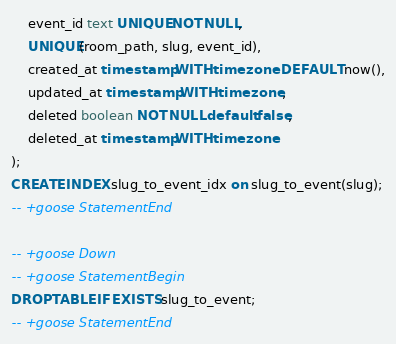Convert code to text. <code><loc_0><loc_0><loc_500><loc_500><_SQL_>    event_id text UNIQUE NOT NULL,
    UNIQUE(room_path, slug, event_id),
    created_at timestamp WITH time zone DEFAULT now(),
    updated_at timestamp WITH time zone,
    deleted boolean NOT NULL default false,
    deleted_at timestamp WITH time zone
);
CREATE INDEX slug_to_event_idx on slug_to_event(slug);
-- +goose StatementEnd

-- +goose Down
-- +goose StatementBegin
DROP TABLE IF EXISTS slug_to_event;
-- +goose StatementEnd
</code> 